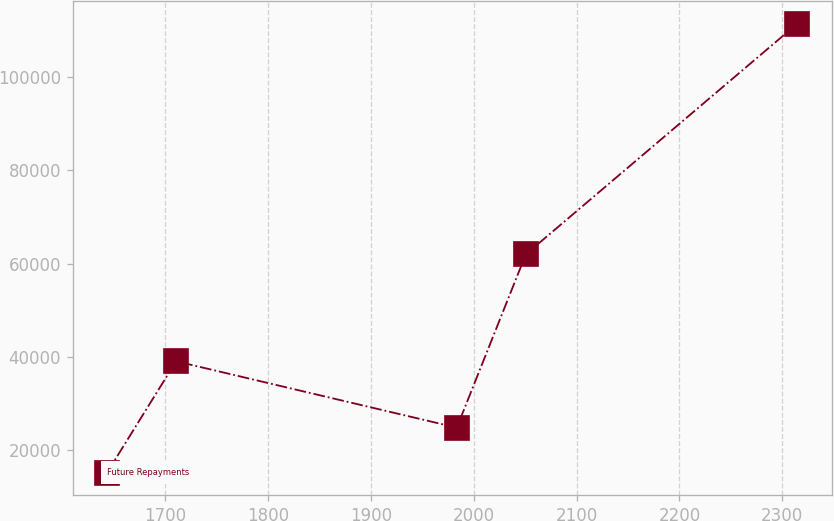Convert chart. <chart><loc_0><loc_0><loc_500><loc_500><line_chart><ecel><fcel>Future Repayments<nl><fcel>1643.53<fcel>15225.8<nl><fcel>1710.65<fcel>39066.1<nl><fcel>1983.52<fcel>24848.1<nl><fcel>2050.64<fcel>61990.8<nl><fcel>2314.74<fcel>111449<nl></chart> 